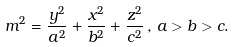<formula> <loc_0><loc_0><loc_500><loc_500>m ^ { 2 } = \frac { y ^ { 2 } } { a ^ { 2 } } + \frac { x ^ { 2 } } { b ^ { 2 } } + \frac { z ^ { 2 } } { c ^ { 2 } } \, , \, a > b > c .</formula> 